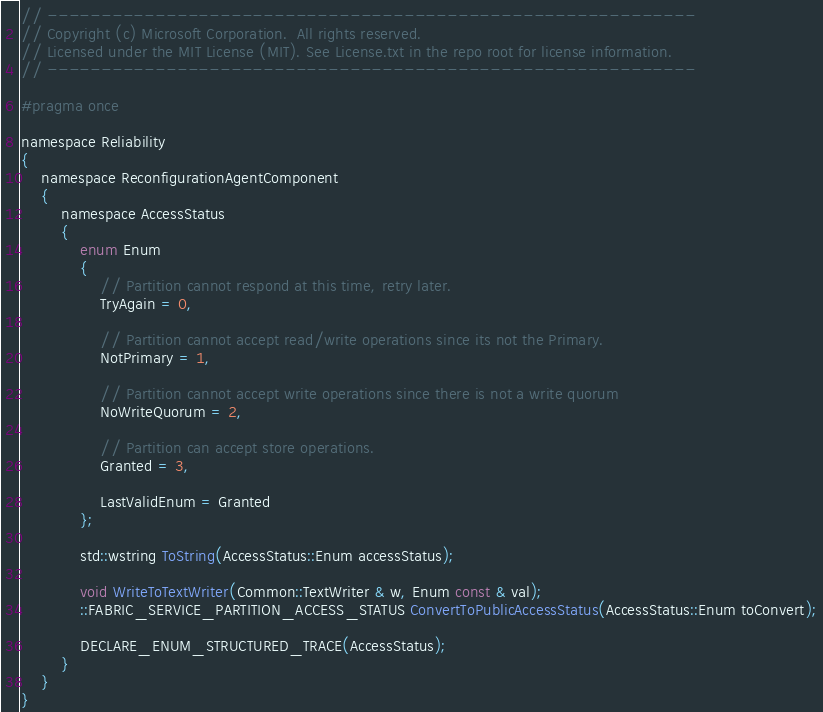<code> <loc_0><loc_0><loc_500><loc_500><_C_>// ------------------------------------------------------------
// Copyright (c) Microsoft Corporation.  All rights reserved.
// Licensed under the MIT License (MIT). See License.txt in the repo root for license information.
// ------------------------------------------------------------

#pragma once

namespace Reliability
{
    namespace ReconfigurationAgentComponent
    {
        namespace AccessStatus
        {
            enum Enum
            {
                // Partition cannot respond at this time, retry later.
                TryAgain = 0,
                
                // Partition cannot accept read/write operations since its not the Primary.
                NotPrimary = 1,
                
                // Partition cannot accept write operations since there is not a write quorum
                NoWriteQuorum = 2,
                
                // Partition can accept store operations.
                Granted = 3,

                LastValidEnum = Granted
            };

            std::wstring ToString(AccessStatus::Enum accessStatus);

            void WriteToTextWriter(Common::TextWriter & w, Enum const & val);
            ::FABRIC_SERVICE_PARTITION_ACCESS_STATUS ConvertToPublicAccessStatus(AccessStatus::Enum toConvert);

            DECLARE_ENUM_STRUCTURED_TRACE(AccessStatus);
        }
    }
}
</code> 